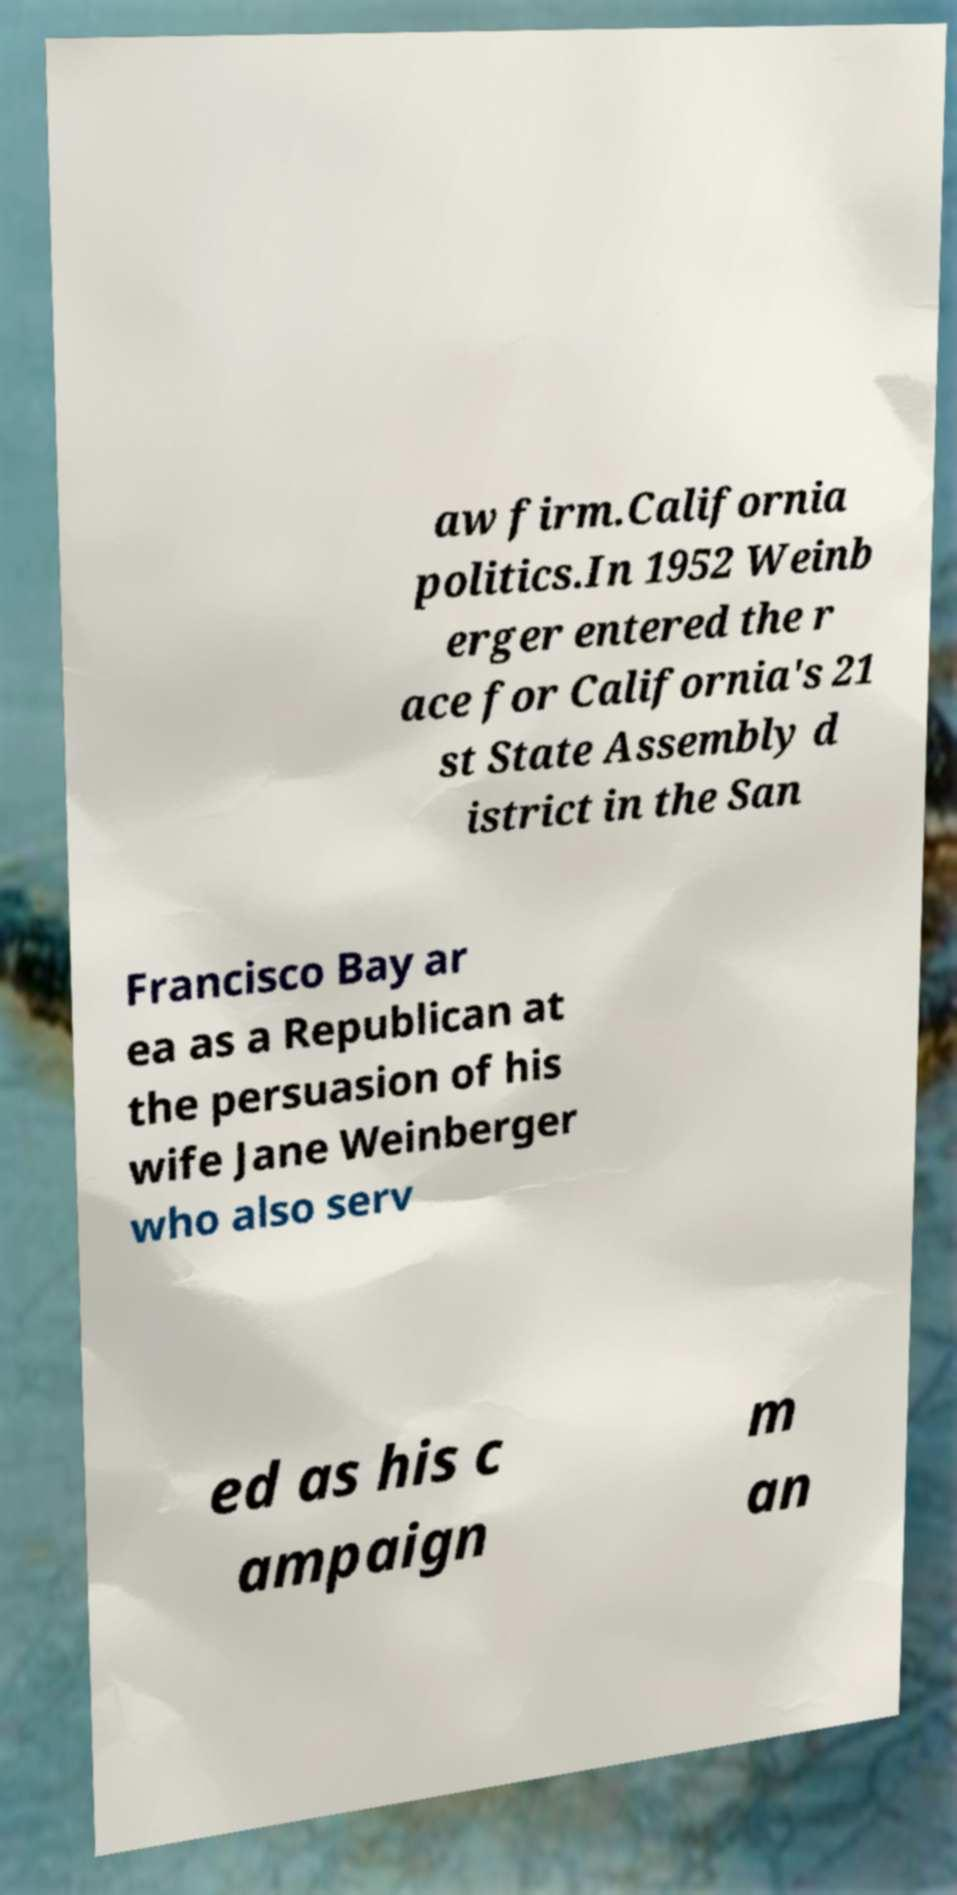I need the written content from this picture converted into text. Can you do that? aw firm.California politics.In 1952 Weinb erger entered the r ace for California's 21 st State Assembly d istrict in the San Francisco Bay ar ea as a Republican at the persuasion of his wife Jane Weinberger who also serv ed as his c ampaign m an 